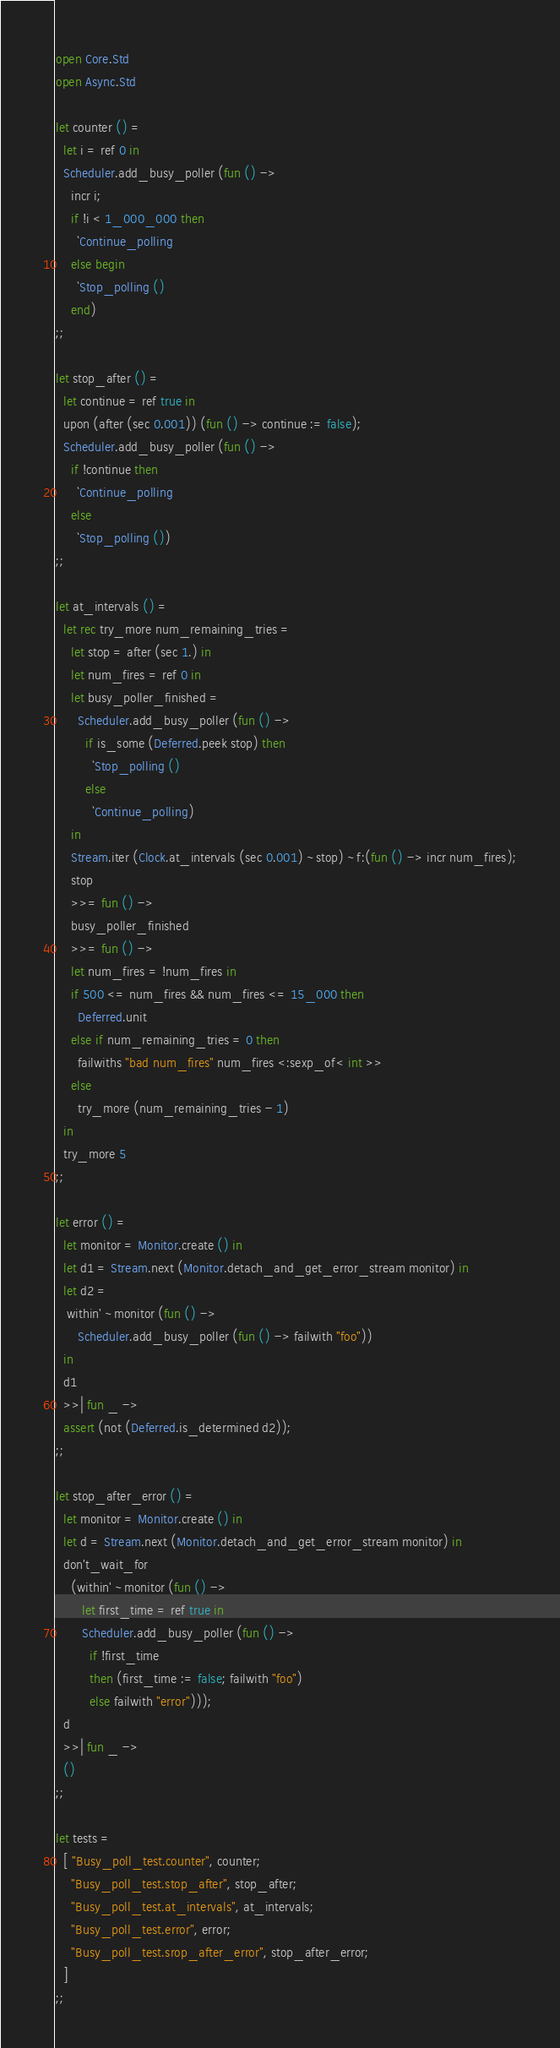Convert code to text. <code><loc_0><loc_0><loc_500><loc_500><_OCaml_>open Core.Std
open Async.Std

let counter () =
  let i = ref 0 in
  Scheduler.add_busy_poller (fun () ->
    incr i;
    if !i < 1_000_000 then
      `Continue_polling
    else begin
      `Stop_polling ()
    end)
;;

let stop_after () =
  let continue = ref true in
  upon (after (sec 0.001)) (fun () -> continue := false);
  Scheduler.add_busy_poller (fun () ->
    if !continue then
      `Continue_polling
    else
      `Stop_polling ())
;;

let at_intervals () =
  let rec try_more num_remaining_tries =
    let stop = after (sec 1.) in
    let num_fires = ref 0 in
    let busy_poller_finished =
      Scheduler.add_busy_poller (fun () ->
        if is_some (Deferred.peek stop) then
          `Stop_polling ()
        else
          `Continue_polling)
    in
    Stream.iter (Clock.at_intervals (sec 0.001) ~stop) ~f:(fun () -> incr num_fires);
    stop
    >>= fun () ->
    busy_poller_finished
    >>= fun () ->
    let num_fires = !num_fires in
    if 500 <= num_fires && num_fires <= 15_000 then
      Deferred.unit
    else if num_remaining_tries = 0 then
      failwiths "bad num_fires" num_fires <:sexp_of< int >>
    else
      try_more (num_remaining_tries - 1)
  in
  try_more 5
;;

let error () =
  let monitor = Monitor.create () in
  let d1 = Stream.next (Monitor.detach_and_get_error_stream monitor) in
  let d2 =
   within' ~monitor (fun () ->
      Scheduler.add_busy_poller (fun () -> failwith "foo"))
  in
  d1
  >>| fun _ ->
  assert (not (Deferred.is_determined d2));
;;

let stop_after_error () =
  let monitor = Monitor.create () in
  let d = Stream.next (Monitor.detach_and_get_error_stream monitor) in
  don't_wait_for
    (within' ~monitor (fun () ->
       let first_time = ref true in
       Scheduler.add_busy_poller (fun () ->
         if !first_time
         then (first_time := false; failwith "foo")
         else failwith "error")));
  d
  >>| fun _ ->
  ()
;;

let tests =
  [ "Busy_poll_test.counter", counter;
    "Busy_poll_test.stop_after", stop_after;
    "Busy_poll_test.at_intervals", at_intervals;
    "Busy_poll_test.error", error;
    "Busy_poll_test.srop_after_error", stop_after_error;
  ]
;;
</code> 